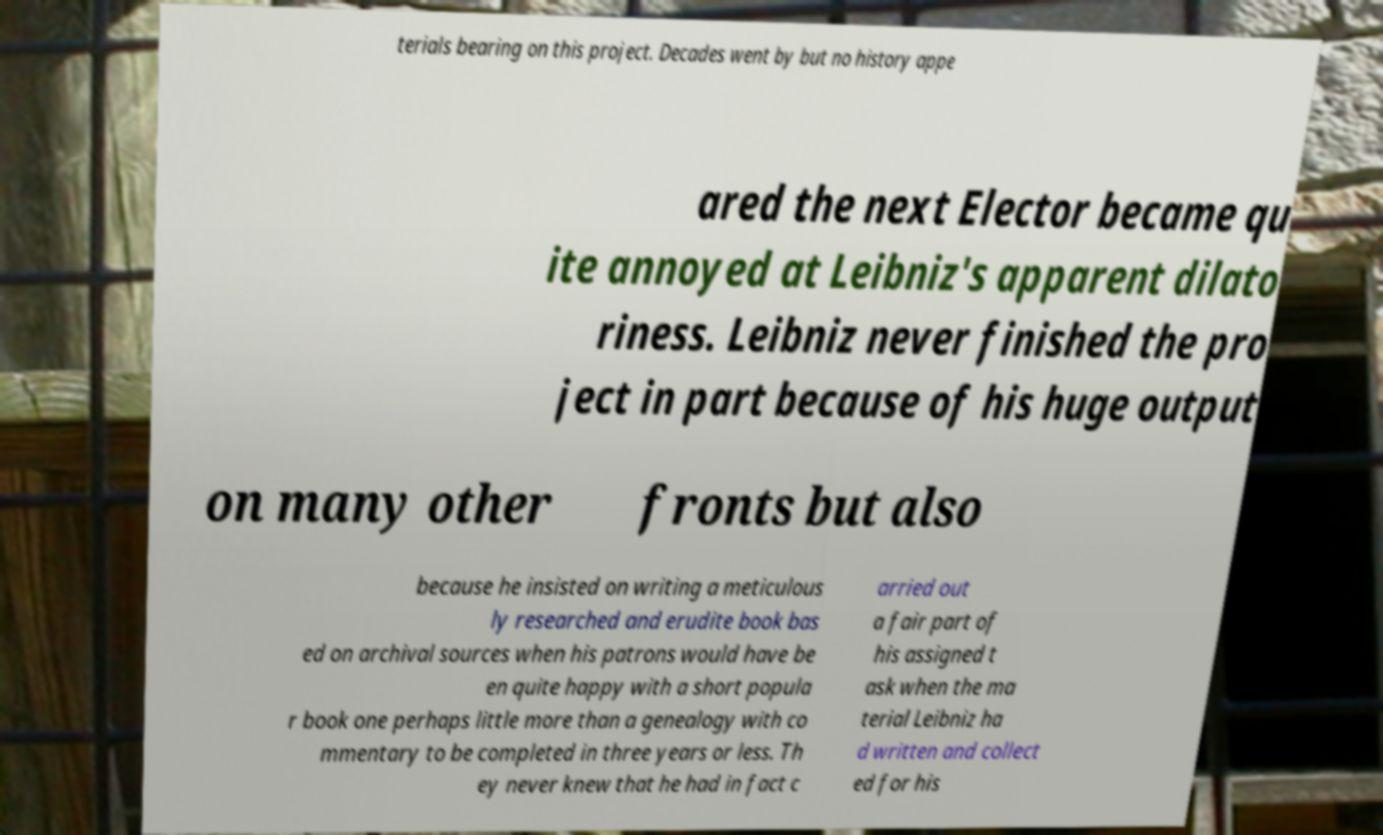Could you extract and type out the text from this image? terials bearing on this project. Decades went by but no history appe ared the next Elector became qu ite annoyed at Leibniz's apparent dilato riness. Leibniz never finished the pro ject in part because of his huge output on many other fronts but also because he insisted on writing a meticulous ly researched and erudite book bas ed on archival sources when his patrons would have be en quite happy with a short popula r book one perhaps little more than a genealogy with co mmentary to be completed in three years or less. Th ey never knew that he had in fact c arried out a fair part of his assigned t ask when the ma terial Leibniz ha d written and collect ed for his 